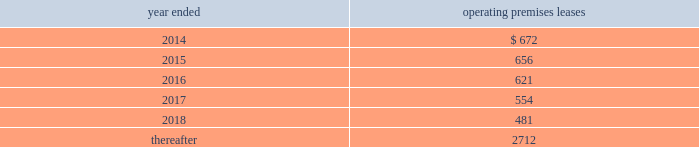Morgan stanley notes to consolidated financial statements 2014 ( continued ) lending commitments .
Primary lending commitments are those that are originated by the company whereas secondary lending commitments are purchased from third parties in the market .
The commitments include lending commitments that are made to investment grade and non-investment grade companies in connection with corporate lending and other business activities .
Commitments for secured lending transactions .
Secured lending commitments are extended by the company to companies and are secured by real estate or other physical assets of the borrower .
Loans made under these arrangements typically are at variable rates and generally provide for over-collateralization based upon the creditworthiness of the borrower .
Forward starting reverse repurchase agreements .
The company has entered into forward starting securities purchased under agreements to resell ( agreements that have a trade date at or prior to december 31 , 2013 and settle subsequent to period-end ) that are primarily secured by collateral from u.s .
Government agency securities and other sovereign government obligations .
Commercial and residential mortgage-related commitments .
The company enters into forward purchase contracts involving residential mortgage loans , residential mortgage lending commitments to individuals and residential home equity lines of credit .
In addition , the company enters into commitments to originate commercial and residential mortgage loans .
Underwriting commitments .
The company provides underwriting commitments in connection with its capital raising sources to a diverse group of corporate and other institutional clients .
Other lending commitments .
Other commitments generally include commercial lending commitments to small businesses and commitments related to securities-based lending activities in connection with the company 2019s wealth management business segment .
The company sponsors several non-consolidated investment funds for third-party investors where the company typically acts as general partner of , and investment advisor to , these funds and typically commits to invest a minority of the capital of such funds , with subscribing third-party investors contributing the majority .
The company 2019s employees , including its senior officers , as well as the company 2019s directors , may participate on the same terms and conditions as other investors in certain of these funds that the company forms primarily for client investment , except that the company may waive or lower applicable fees and charges for its employees .
The company has contractual capital commitments , guarantees , lending facilities and counterparty arrangements with respect to these investment funds .
Premises and equipment .
The company has non-cancelable operating leases covering premises and equipment ( excluding commodities operating leases , shown separately ) .
At december 31 , 2013 , future minimum rental commitments under such leases ( net of subleases , principally on office rentals ) were as follows ( dollars in millions ) : year ended operating premises leases .

What is the percentage difference in future minimum rental commitments as of december 31 , 2013 between 2015 and 2016? 
Computations: ((621 - 656) / 656)
Answer: -0.05335. 